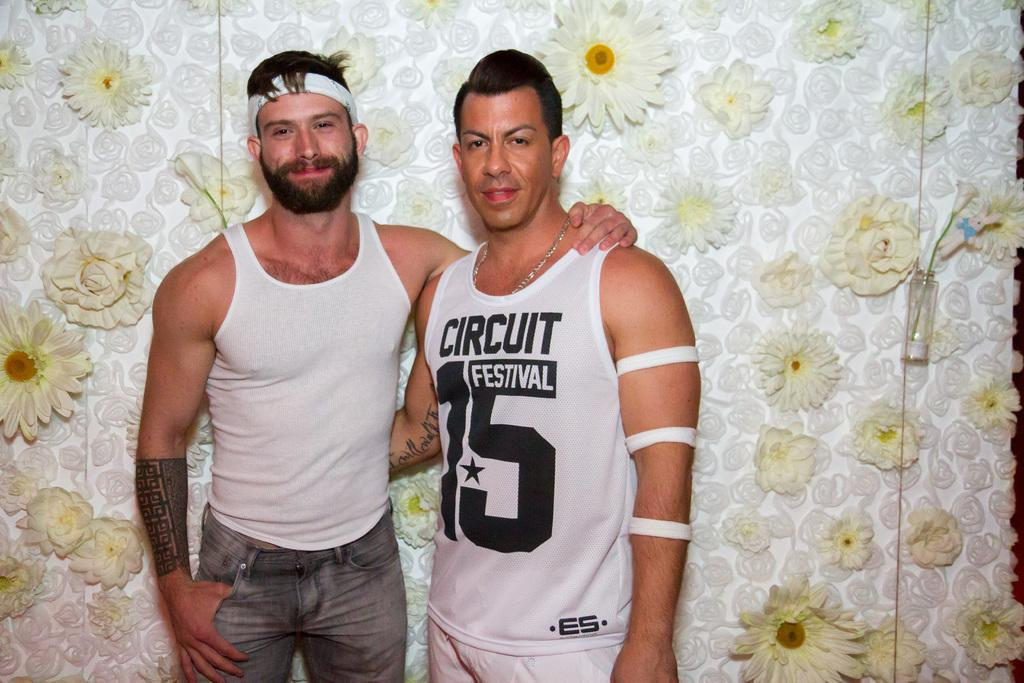<image>
Give a short and clear explanation of the subsequent image. the man on the right is wearing a top with Circuit 15 on it 